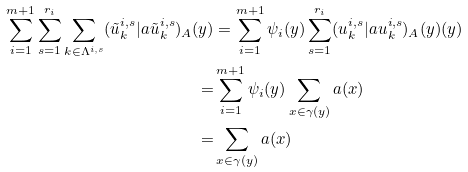Convert formula to latex. <formula><loc_0><loc_0><loc_500><loc_500>\sum _ { i = 1 } ^ { m + 1 } \sum _ { s = 1 } ^ { r _ { i } } \sum _ { k \in \Lambda ^ { i , s } } ( \tilde { u } ^ { i , s } _ { k } | a \tilde { u } ^ { i , s } _ { k } ) _ { A } ( y ) & = \sum _ { i = 1 } ^ { m + 1 } \psi _ { i } ( y ) \sum _ { s = 1 } ^ { r _ { i } } ( u ^ { i , s } _ { k } | a u ^ { i , s } _ { k } ) _ { A } ( y ) ( y ) \\ = & \sum _ { i = 1 } ^ { m + 1 } \psi _ { i } ( y ) \sum _ { x \in \gamma ( y ) } a ( x ) \\ = & \sum _ { x \in \gamma ( y ) } a ( x )</formula> 